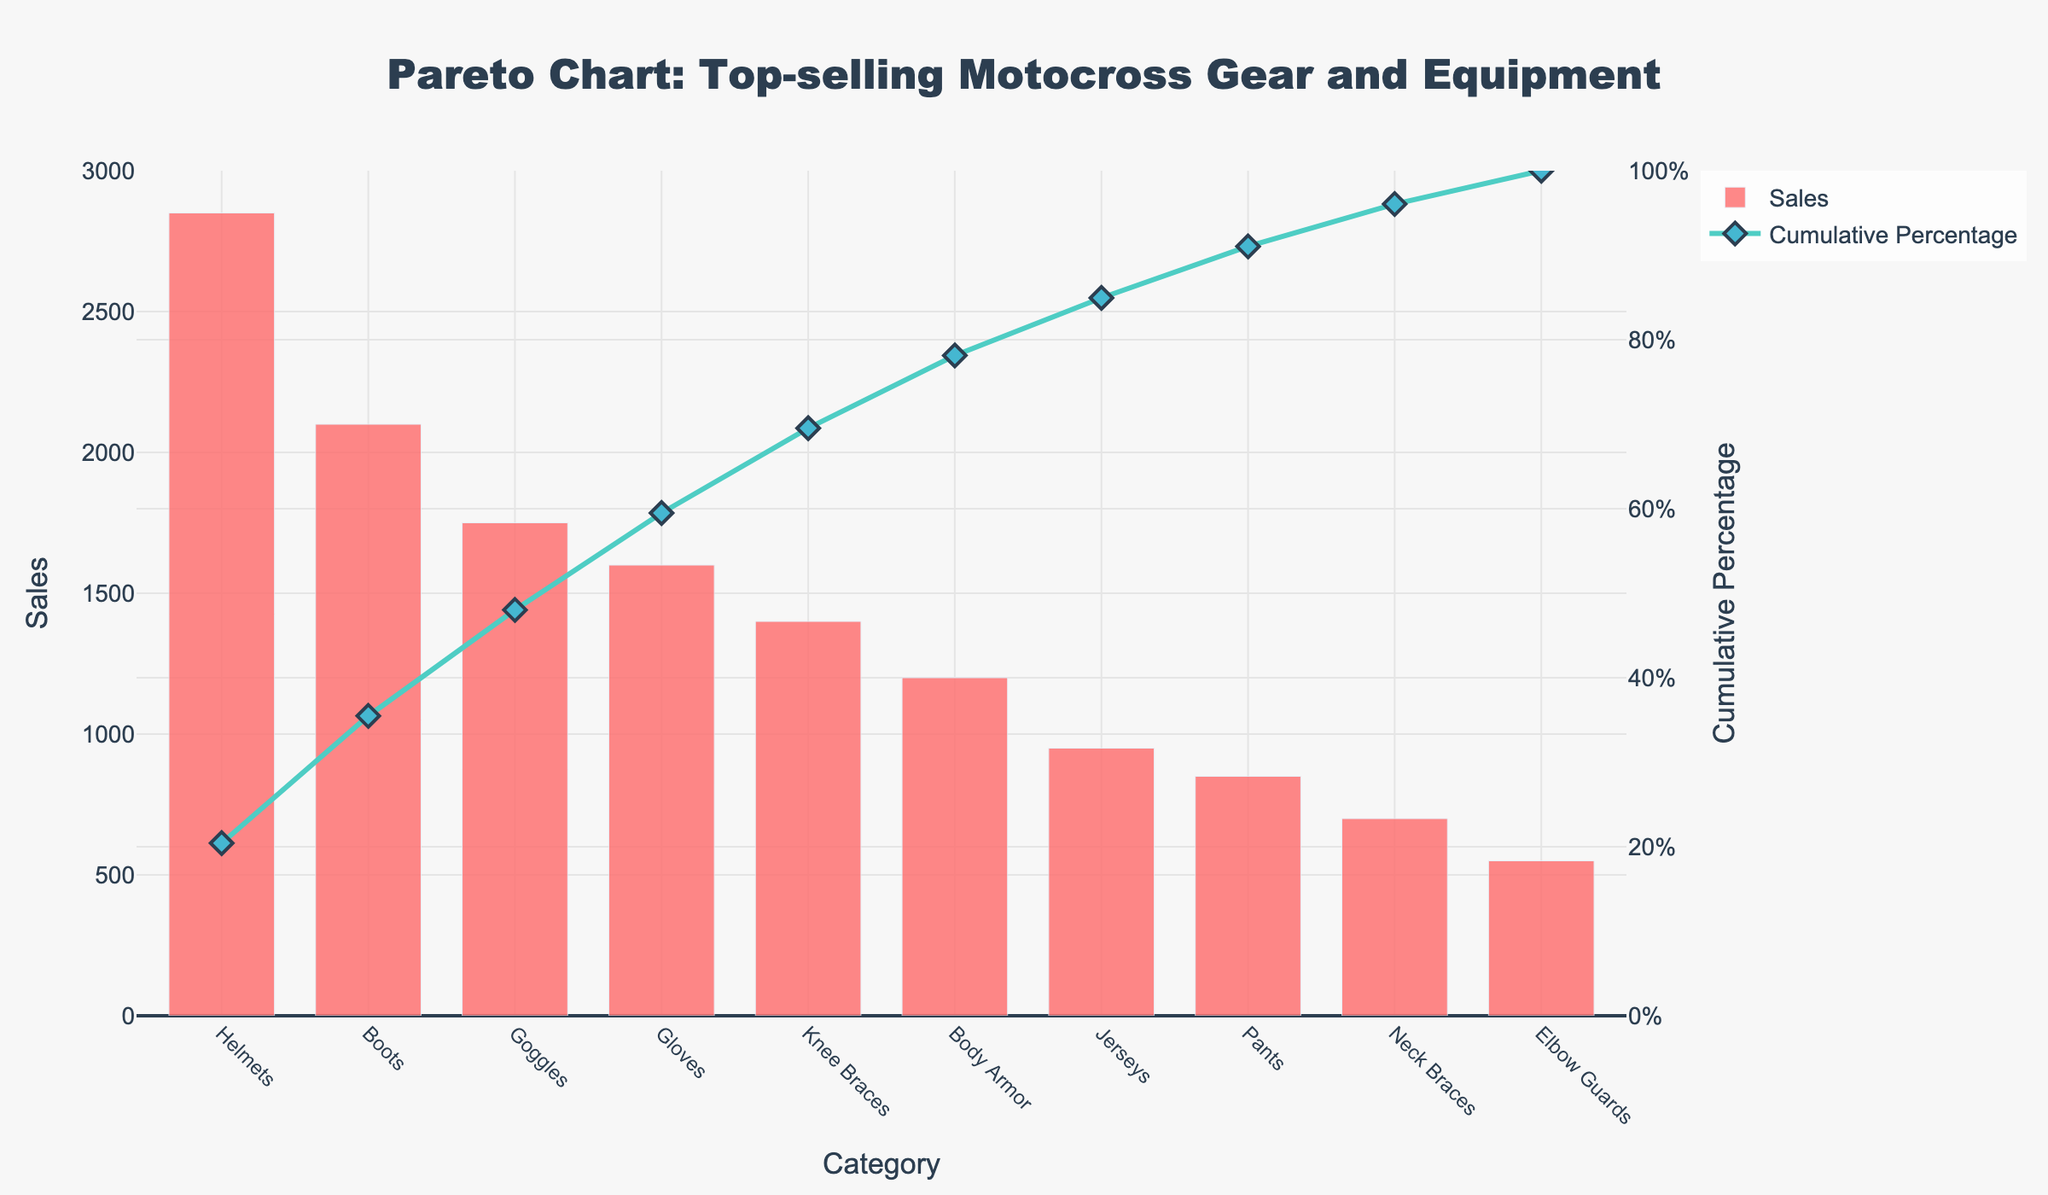what is the top-selling category? The top-selling category can be directly seen from the bar chart. The category with the highest bar represents the most sales. In this case, the "Helmets" category has the highest bar.
Answer: Helmets What percentage of total sales do helmets represent? The cumulative percentage line shows the proportion of total sales. In this case, the cumulative percentage for the "Helmets" category can be read from the second y-axis on the right. It’s around 22%.
Answer: 22% What are the categories listed in the chart? The categories are listed along the x-axis of the chart. They include Helmets, Boots, Goggles, Gloves, Knee Braces, Body Armor, Jerseys, Pants, Neck Braces, and Elbow Guards.
Answer: Helmets, Boots, Goggles, Gloves, Knee Braces, Body Armor, Jerseys, Pants, Neck Braces, Elbow Guards How much more did helmets sell compared to elbow guards? The sales figures are shown by the height of the bars. Helmets sold 2850 units and elbow guards sold 550 units. The difference is calculated by subtracting these values: 2850 - 550.
Answer: 2300 How does the cumulative percentage related to the individual sales quantities? The cumulative percentage line shows the sum of sales up to that category as a percent of total sales. For instance, after Helmets, the percent is around 22%; after Boots, it’s increased to about 38%. This demonstrates the cumulative sales impact.
Answer: Shows cumulative impact Which categories contribute to the top 50% of sales? The cumulative percentage line helps in identifying this. By checking the y2-axis for 50%, we see categories Helmets, Boots, Goggles, and Gloves cumulatively reach just over 50%.
Answer: Helmets, Boots, Goggles, Gloves What is the cumulative percentage after Body Armor is included? The cumulative percentage after each category is indicated by the line graph. After Body Armor is included, the cumulative percentage is around 75%.
Answer: 75% How many categories are necessary to produce 80% of total sales? The cumulative percentage line provides this information. We need to count the categories up to the point where the cumulative percentage reaches or exceeds 80%. This includes Helmets, Boots, Goggles, Gloves, Knee Braces, and Body Armor.
Answer: 6 What is the difference in sales between the highest and lowest-selling categories? The highest-selling category (Helmets) sold 2850 units, and the lowest-selling category (Elbow Guards) sold 550 units. The difference is 2850 - 550.
Answer: 2300 What is the color of the cumulative percentage line in the plot? The color of the cumulative percentage line is shown in the legend and the actual line. It’s a teal color.
Answer: teal 